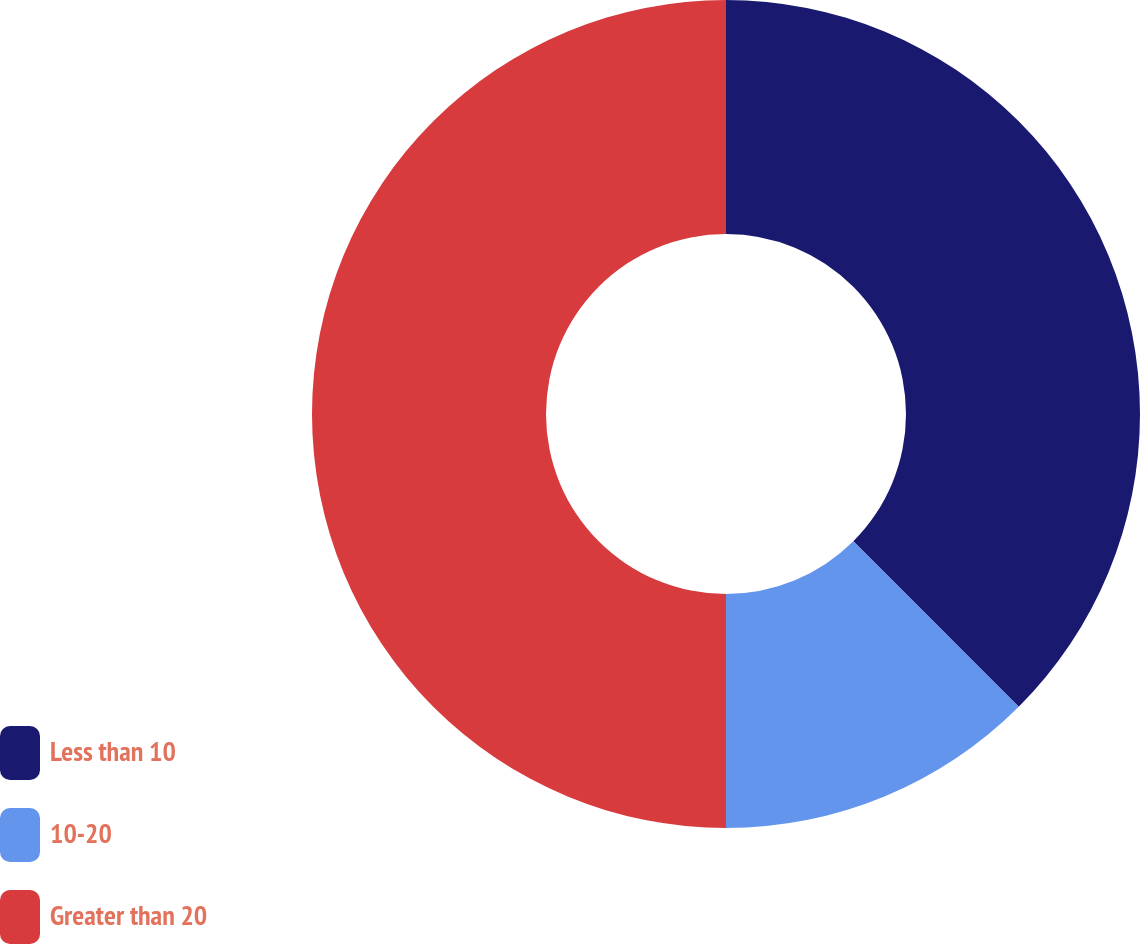Convert chart. <chart><loc_0><loc_0><loc_500><loc_500><pie_chart><fcel>Less than 10<fcel>10-20<fcel>Greater than 20<nl><fcel>37.5%<fcel>12.5%<fcel>50.0%<nl></chart> 